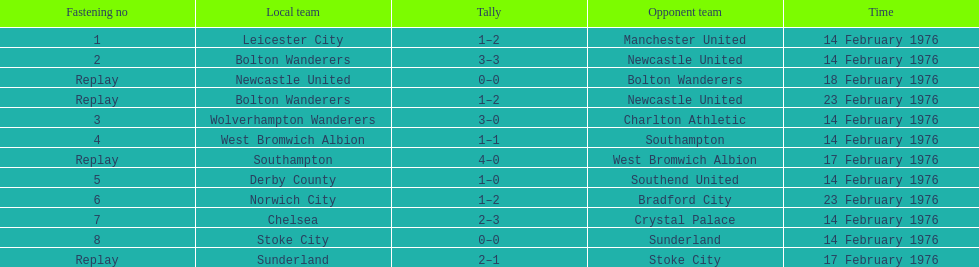What was the number of games that occurred on 14 february 1976? 7. 